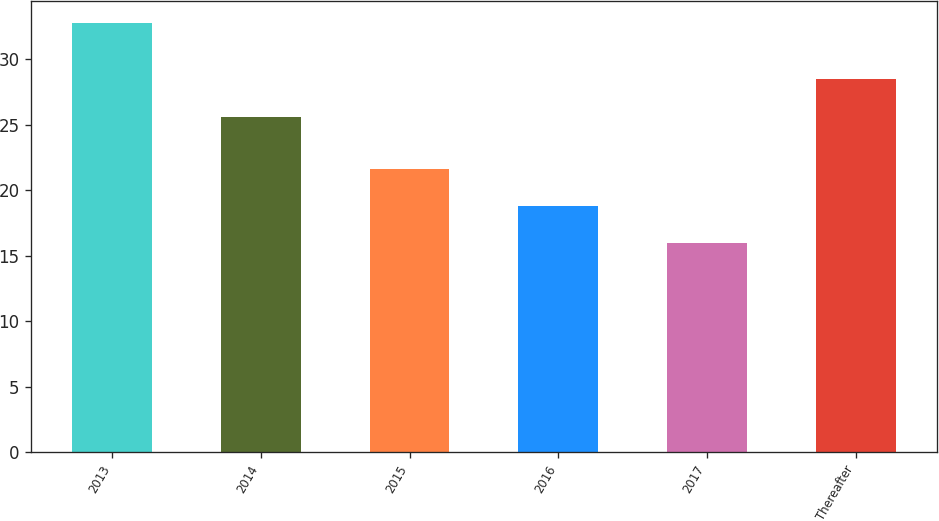<chart> <loc_0><loc_0><loc_500><loc_500><bar_chart><fcel>2013<fcel>2014<fcel>2015<fcel>2016<fcel>2017<fcel>Thereafter<nl><fcel>32.8<fcel>25.6<fcel>21.6<fcel>18.8<fcel>16<fcel>28.5<nl></chart> 